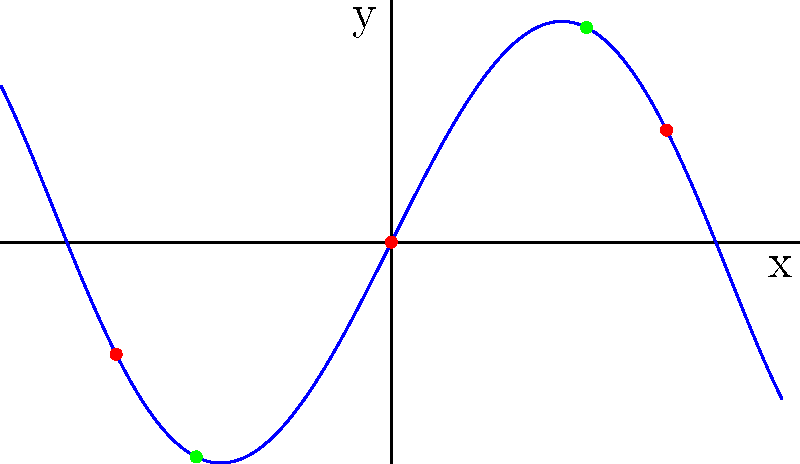The graph shows a fifth-degree polynomial function $f(x) = 0.1x^5 - x^3 + 2x$. Identify the number of turning points and inflection points in the given interval $[-2, 2]$. What do these points tell us about the behavior of the function? To find the turning points and inflection points, we need to analyze the first and second derivatives of the function.

1. Turning points (red dots):
   - Found where $f'(x) = 0$
   - $f'(x) = 0.5x^4 - 3x^2 + 2$
   - Solving $f'(x) = 0$, we get $x \approx -1.41, 0, 1.41$
   - There are 3 turning points in the interval $[-2, 2]$

2. Inflection points (green dots):
   - Found where $f''(x) = 0$
   - $f''(x) = 2x^3 - 6x$
   - Solving $f''(x) = 0$, we get $x = -1, 0, 1$
   - There are 3 inflection points, but only 2 are visible in the interval $[-2, 2]$

3. Behavior of the function:
   - Turning points indicate where the function changes from increasing to decreasing or vice versa
   - Inflection points show where the concavity of the function changes

In this case, the function has 3 turning points and 2 visible inflection points, demonstrating the complexity of a fifth-degree polynomial with multiple changes in direction and concavity.
Answer: 3 turning points, 2 visible inflection points; indicates multiple changes in direction and concavity 